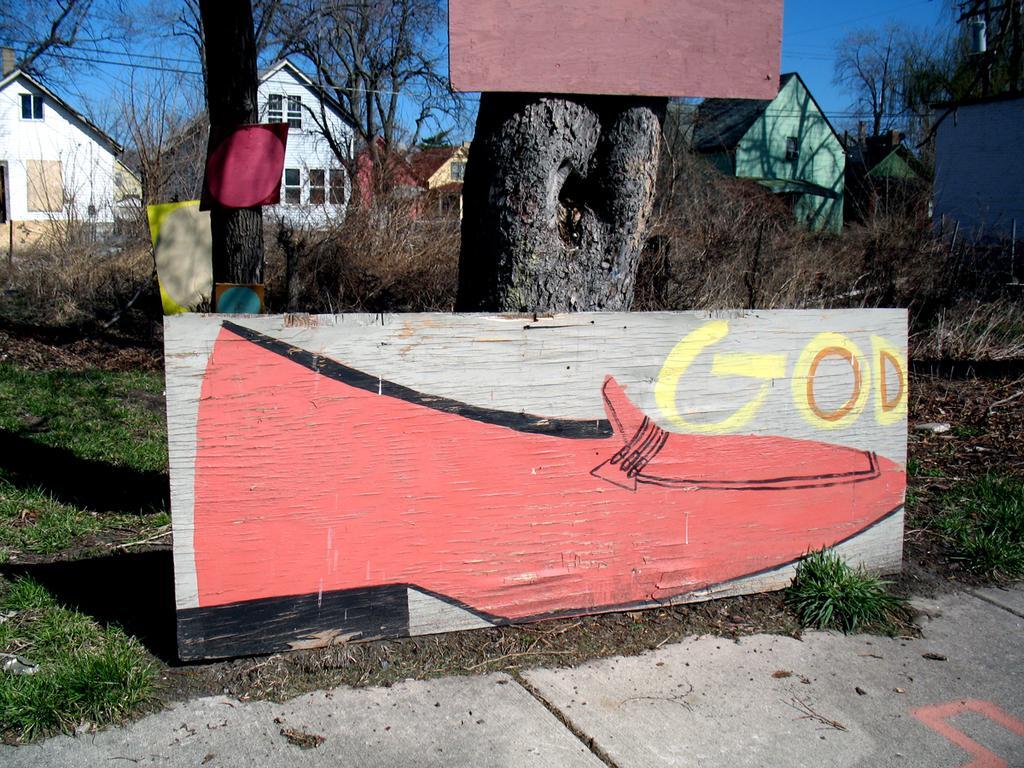In one or two sentences, can you explain what this image depicts? In this picture there is a poster in the center of the image in front of the trunk and there are posters in the image and there are houses and trees in the background area of the image. 